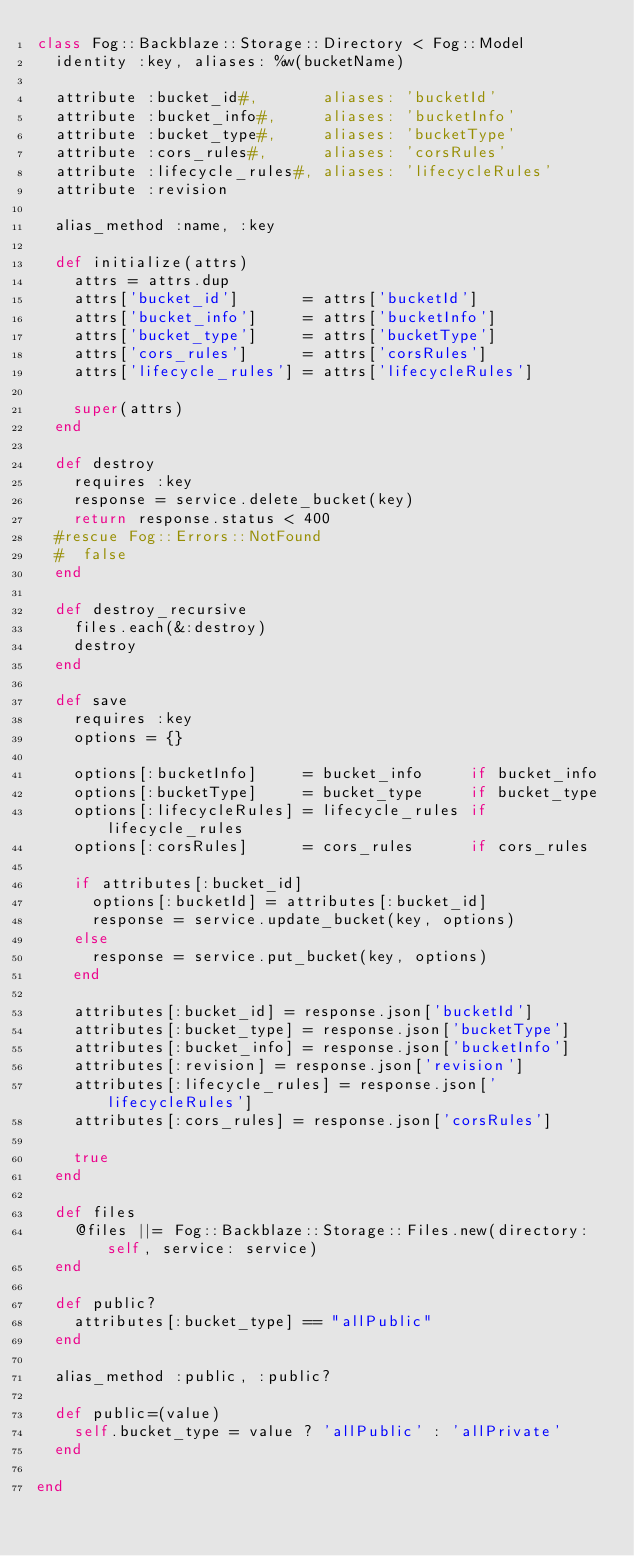Convert code to text. <code><loc_0><loc_0><loc_500><loc_500><_Ruby_>class Fog::Backblaze::Storage::Directory < Fog::Model
  identity :key, aliases: %w(bucketName)

  attribute :bucket_id#,       aliases: 'bucketId'
  attribute :bucket_info#,     aliases: 'bucketInfo'
  attribute :bucket_type#,     aliases: 'bucketType'
  attribute :cors_rules#,      aliases: 'corsRules'
  attribute :lifecycle_rules#, aliases: 'lifecycleRules'
  attribute :revision

  alias_method :name, :key

  def initialize(attrs)
    attrs = attrs.dup
    attrs['bucket_id']       = attrs['bucketId']
    attrs['bucket_info']     = attrs['bucketInfo']
    attrs['bucket_type']     = attrs['bucketType']
    attrs['cors_rules']      = attrs['corsRules']
    attrs['lifecycle_rules'] = attrs['lifecycleRules']

    super(attrs)
  end

  def destroy
    requires :key
    response = service.delete_bucket(key)
    return response.status < 400
  #rescue Fog::Errors::NotFound
  #  false
  end

  def destroy_recursive
    files.each(&:destroy)
    destroy
  end

  def save
    requires :key
    options = {}

    options[:bucketInfo]     = bucket_info     if bucket_info
    options[:bucketType]     = bucket_type     if bucket_type
    options[:lifecycleRules] = lifecycle_rules if lifecycle_rules
    options[:corsRules]      = cors_rules      if cors_rules

    if attributes[:bucket_id]
      options[:bucketId] = attributes[:bucket_id]
      response = service.update_bucket(key, options)
    else
      response = service.put_bucket(key, options)
    end

    attributes[:bucket_id] = response.json['bucketId']
    attributes[:bucket_type] = response.json['bucketType']
    attributes[:bucket_info] = response.json['bucketInfo']
    attributes[:revision] = response.json['revision']
    attributes[:lifecycle_rules] = response.json['lifecycleRules']
    attributes[:cors_rules] = response.json['corsRules']

    true
  end

  def files
    @files ||= Fog::Backblaze::Storage::Files.new(directory: self, service: service)
  end

  def public?
    attributes[:bucket_type] == "allPublic"
  end

  alias_method :public, :public?

  def public=(value)
    self.bucket_type = value ? 'allPublic' : 'allPrivate'
  end

end
</code> 